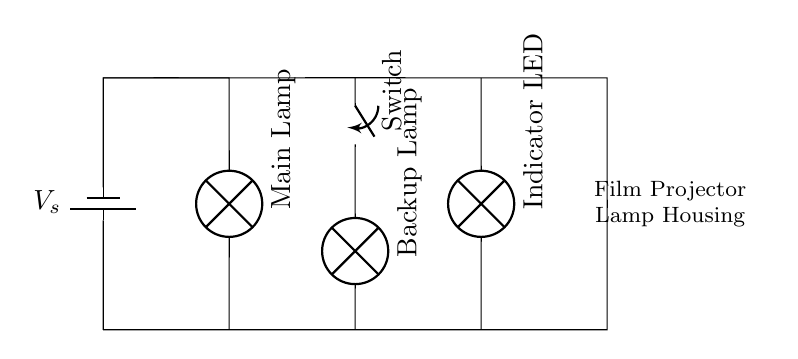What components are present in the circuit? The circuit contains a battery, a main lamp, a backup lamp, a switch, and an indicator LED. These components are clearly labeled in the diagram.
Answer: battery, main lamp, backup lamp, switch, indicator LED How many lamps are connected in this circuit? There are two lamps in the circuit: the main lamp and the backup lamp. Each lamp is identified in the diagram.
Answer: two What is the function of the switch in this circuit? The switch controls the connection to the backup lamp. When the switch is closed, the backup lamp is activated for illumination.
Answer: control backup lamp Is this a series or parallel circuit? The circuit is a parallel circuit as the lamps are connected side by side, allowing each to operate independently of the other.
Answer: parallel What will happen if the main lamp fails? If the main lamp fails, the backup lamp can still function because they are connected in parallel, ensuring continued illumination.
Answer: backup lamp works Which component provides the power supply in this circuit? The battery serves as the power supply, providing the necessary voltage to all components.
Answer: battery 